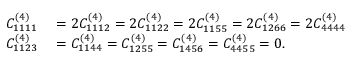Convert formula to latex. <formula><loc_0><loc_0><loc_500><loc_500>\begin{array} { r l } { C _ { 1 1 1 1 } ^ { ( 4 ) } } & = 2 C _ { 1 1 1 2 } ^ { ( 4 ) } = 2 C _ { 1 1 2 2 } ^ { ( 4 ) } = 2 C _ { 1 1 5 5 } ^ { ( 4 ) } = 2 C _ { 1 2 6 6 } ^ { ( 4 ) } = 2 C _ { 4 4 4 4 } ^ { ( 4 ) } } \\ { C _ { 1 1 2 3 } ^ { ( 4 ) } } & = C _ { 1 1 4 4 } ^ { ( 4 ) } = C _ { 1 2 5 5 } ^ { ( 4 ) } = C _ { 1 4 5 6 } ^ { ( 4 ) } = C _ { 4 4 5 5 } ^ { ( 4 ) } = 0 . } \end{array}</formula> 